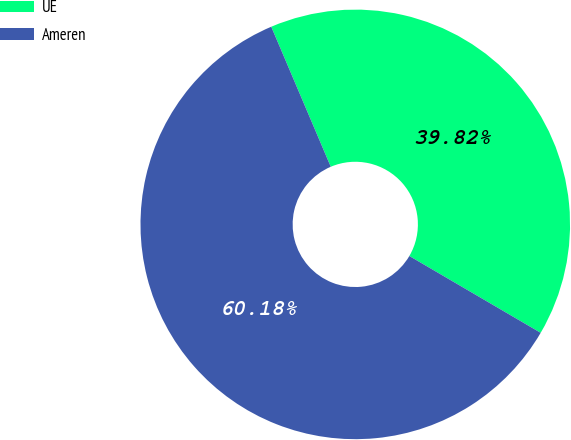Convert chart to OTSL. <chart><loc_0><loc_0><loc_500><loc_500><pie_chart><fcel>UE<fcel>Ameren<nl><fcel>39.82%<fcel>60.18%<nl></chart> 